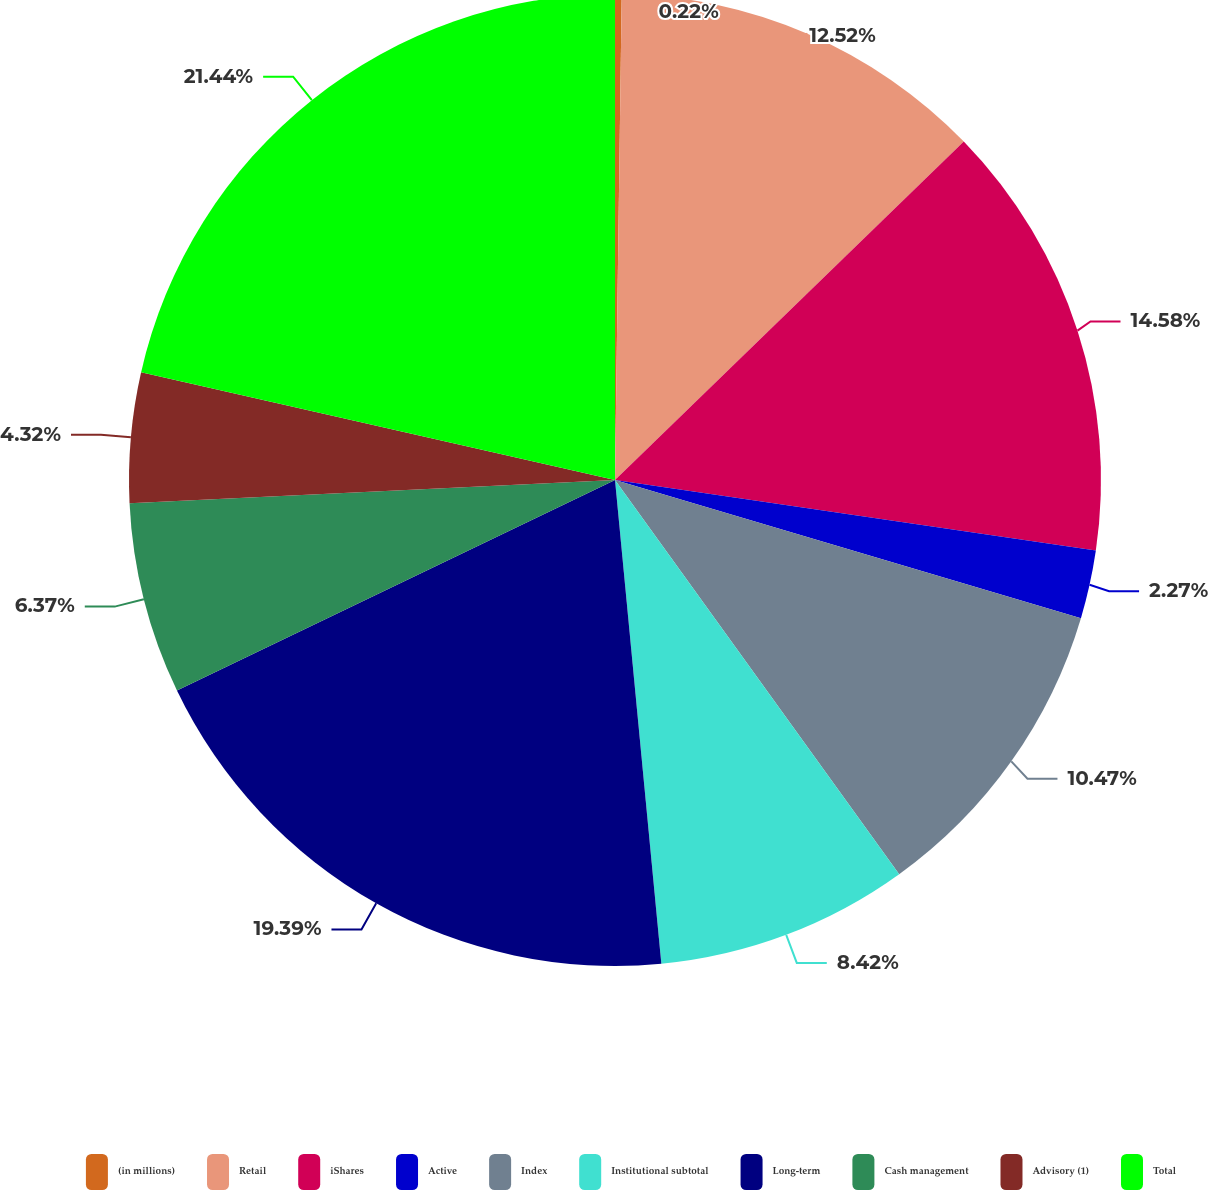Convert chart. <chart><loc_0><loc_0><loc_500><loc_500><pie_chart><fcel>(in millions)<fcel>Retail<fcel>iShares<fcel>Active<fcel>Index<fcel>Institutional subtotal<fcel>Long-term<fcel>Cash management<fcel>Advisory (1)<fcel>Total<nl><fcel>0.22%<fcel>12.52%<fcel>14.58%<fcel>2.27%<fcel>10.47%<fcel>8.42%<fcel>19.39%<fcel>6.37%<fcel>4.32%<fcel>21.44%<nl></chart> 